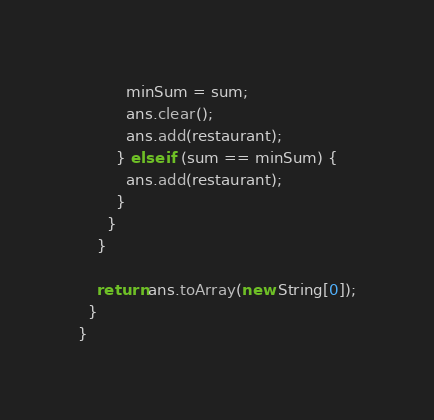Convert code to text. <code><loc_0><loc_0><loc_500><loc_500><_Java_>          minSum = sum;
          ans.clear();
          ans.add(restaurant);
        } else if (sum == minSum) {
          ans.add(restaurant);
        }
      }
    }

    return ans.toArray(new String[0]);
  }
}
</code> 